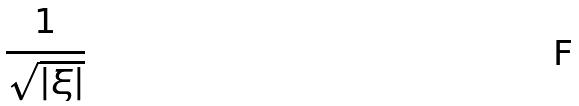Convert formula to latex. <formula><loc_0><loc_0><loc_500><loc_500>\frac { 1 } { \sqrt { | \xi | } }</formula> 